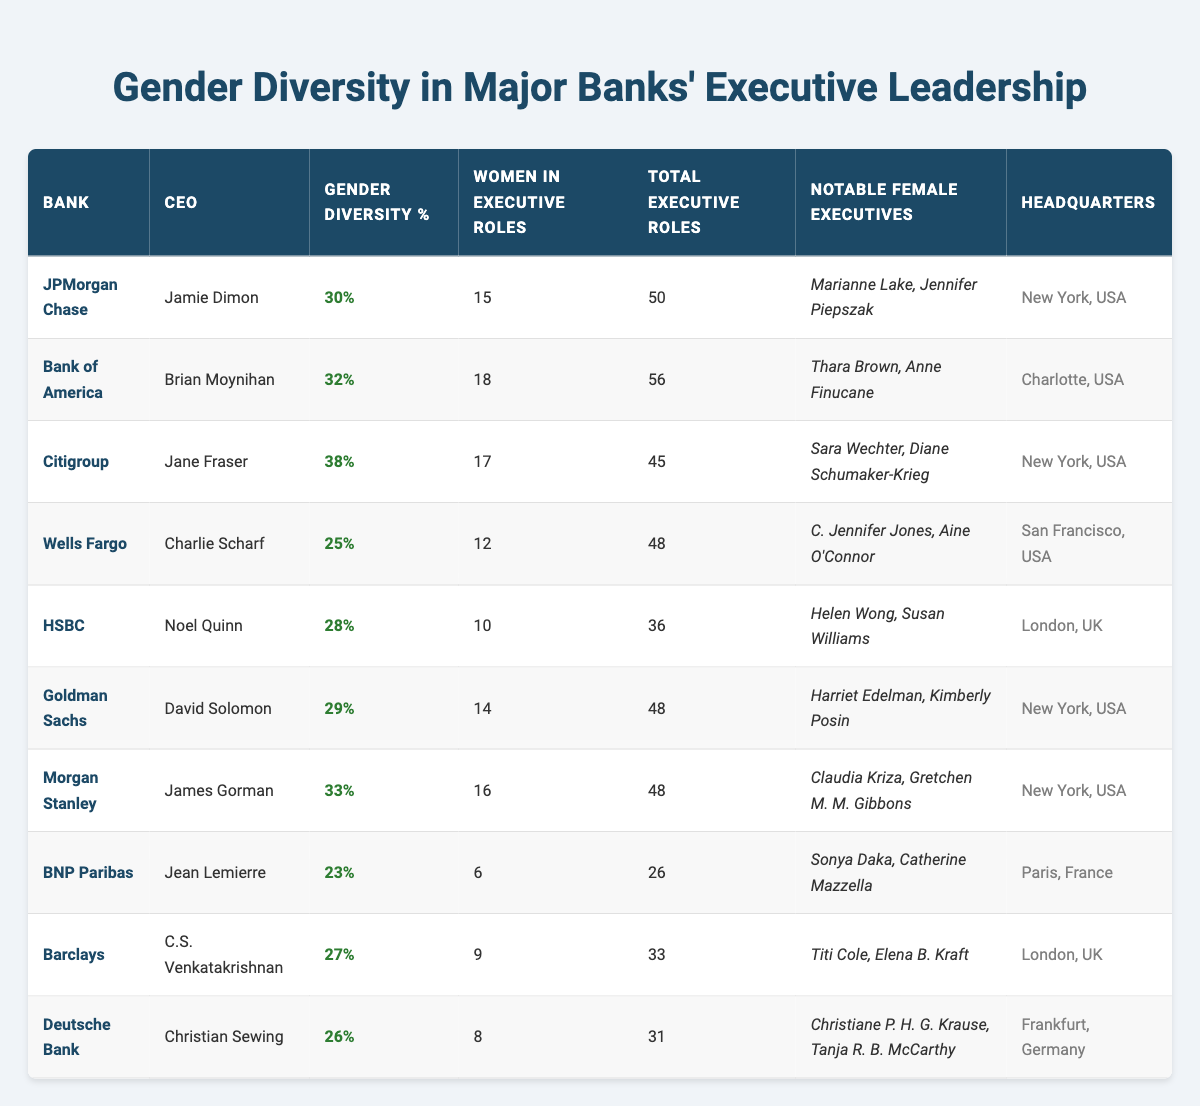What is the gender diversity percentage of Citigroup? The table shows the gender diversity percentage for each bank. For Citigroup, it is specifically listed as 38%.
Answer: 38% Which bank has the highest number of women in executive roles? By reviewing the data, Bank of America has the highest number with 18 women in executive roles.
Answer: Bank of America How many total executive roles does HSBC have? The table explicitly states that HSBC has a total of 36 executive roles listed.
Answer: 36 Is the gender diversity percentage of Morgan Stanley higher than that of Wells Fargo? Morgan Stanley's gender diversity is 33%, while Wells Fargo's is 25%. Since 33% is greater than 25%, the answer is yes.
Answer: Yes What is the average gender diversity percentage of the banks listed? To find the average, we add the percentages: (30 + 32 + 38 + 25 + 28 + 29 + 33 + 23 + 27 + 26) =  29.8. Then we divide by the number of banks, which is 10: 298/10 = 29.8%.
Answer: 29.8% How many banks have a gender diversity percentage above 30%? The percentages above 30% from the table are Citigroup (38%), Bank of America (32%), and Morgan Stanley (33%), making a total of 3 banks.
Answer: 3 Which bank has the least number of women in executive roles? Reviewing the data indicates that BNP Paribas has the least number of women in executive roles, with only 6 women.
Answer: BNP Paribas Is Citigroup's CEO a female or male? The table indicates that Jane Fraser is the CEO of Citigroup, which confirms that the CEO is female.
Answer: Female Calculate the difference in the number of women in executive roles between Goldman Sachs and Barclays. Goldman Sachs has 14 women, and Barclays has 9. The difference is calculated as 14 - 9 = 5.
Answer: 5 Which two banks have the exact total of executive roles? Looking at the table, both Morgan Stanley and Goldman Sachs have a total of 48 executive roles each. Therefore, these two banks match in this category.
Answer: Morgan Stanley and Goldman Sachs 